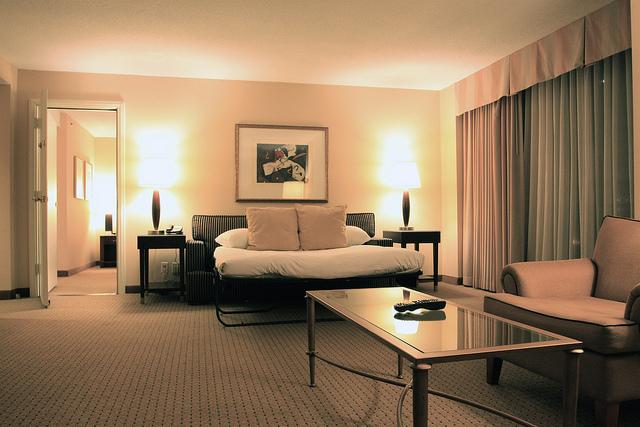What is sitting on the coffee table?
Short answer required. Remote. Is this a living room?
Quick response, please. Yes. Is the table top glass?
Write a very short answer. Yes. Is it day or night?
Concise answer only. Night. 